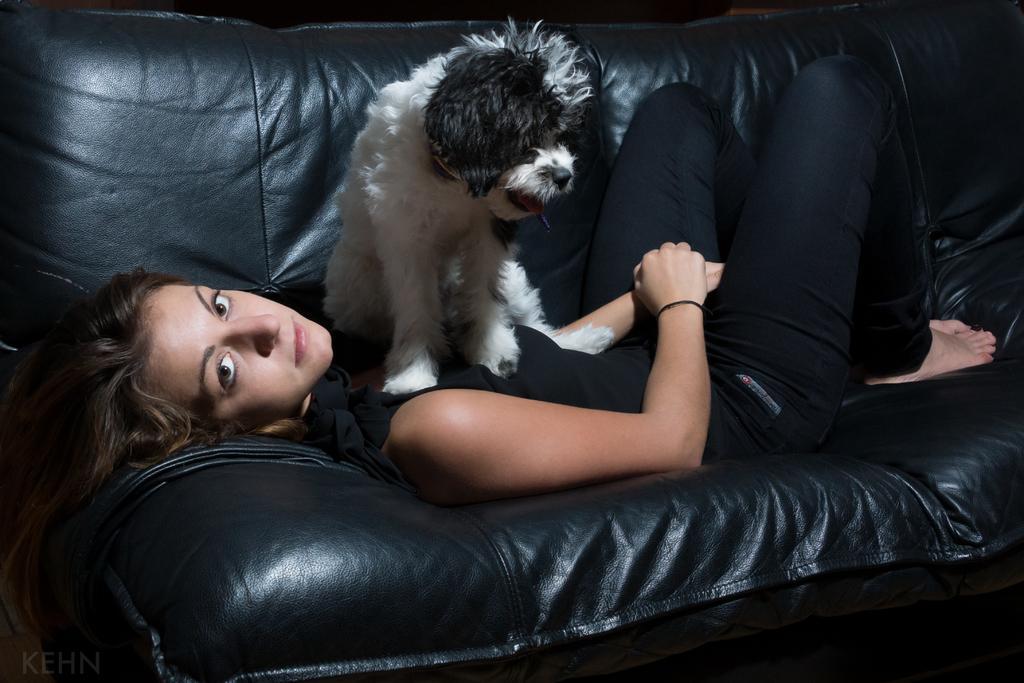Can you describe this image briefly? In this image I can see a woman is lying on a sofa. I can also see a dog on her. 